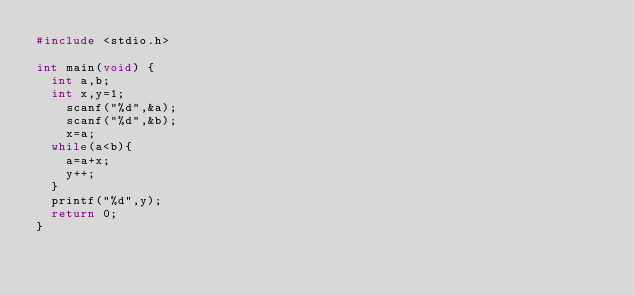Convert code to text. <code><loc_0><loc_0><loc_500><loc_500><_C_>#include <stdio.h>

int main(void) {
  int a,b;
  int x,y=1;
    scanf("%d",&a);
    scanf("%d",&b);
    x=a; 
  while(a<b){
    a=a+x;
    y++;
  }
  printf("%d",y);
  return 0;
}</code> 